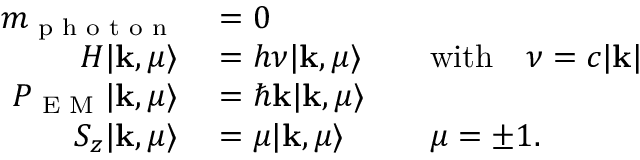Convert formula to latex. <formula><loc_0><loc_0><loc_500><loc_500>\begin{array} { r l r l } { m _ { p h o t o n } } & = 0 } \\ { H | k , \mu \rangle } & = h \nu | k , \mu \rangle } & { w i t h } \quad \nu = c | k | } \\ { P _ { E M } | k , \mu \rangle } & = \hbar { k } | k , \mu \rangle } \\ { S _ { z } | k , \mu \rangle } & = \mu | k , \mu \rangle } & \mu = \pm 1 . } \end{array}</formula> 